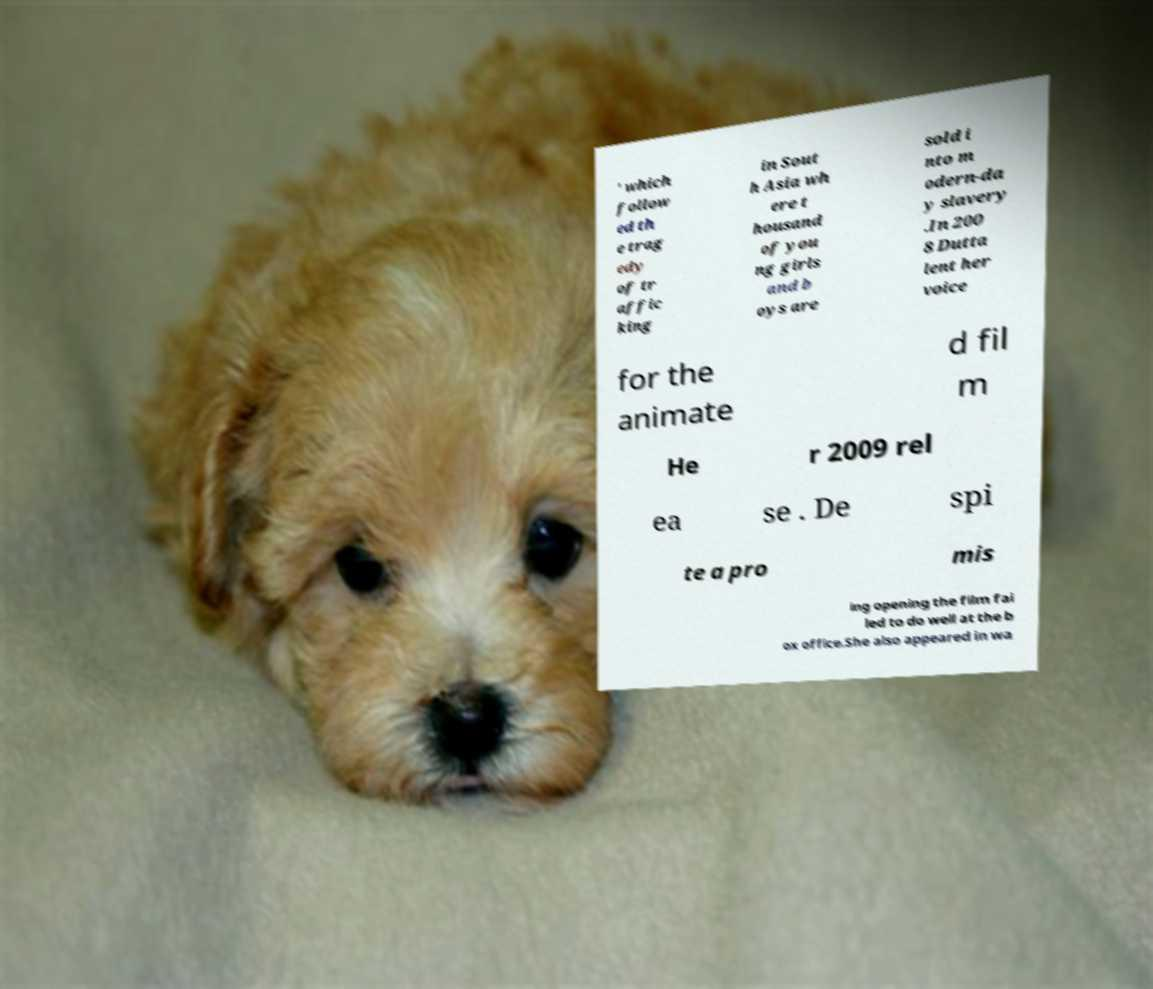What messages or text are displayed in this image? I need them in a readable, typed format. ' which follow ed th e trag edy of tr affic king in Sout h Asia wh ere t housand of you ng girls and b oys are sold i nto m odern-da y slavery .In 200 8 Dutta lent her voice for the animate d fil m He r 2009 rel ea se . De spi te a pro mis ing opening the film fai led to do well at the b ox office.She also appeared in wa 